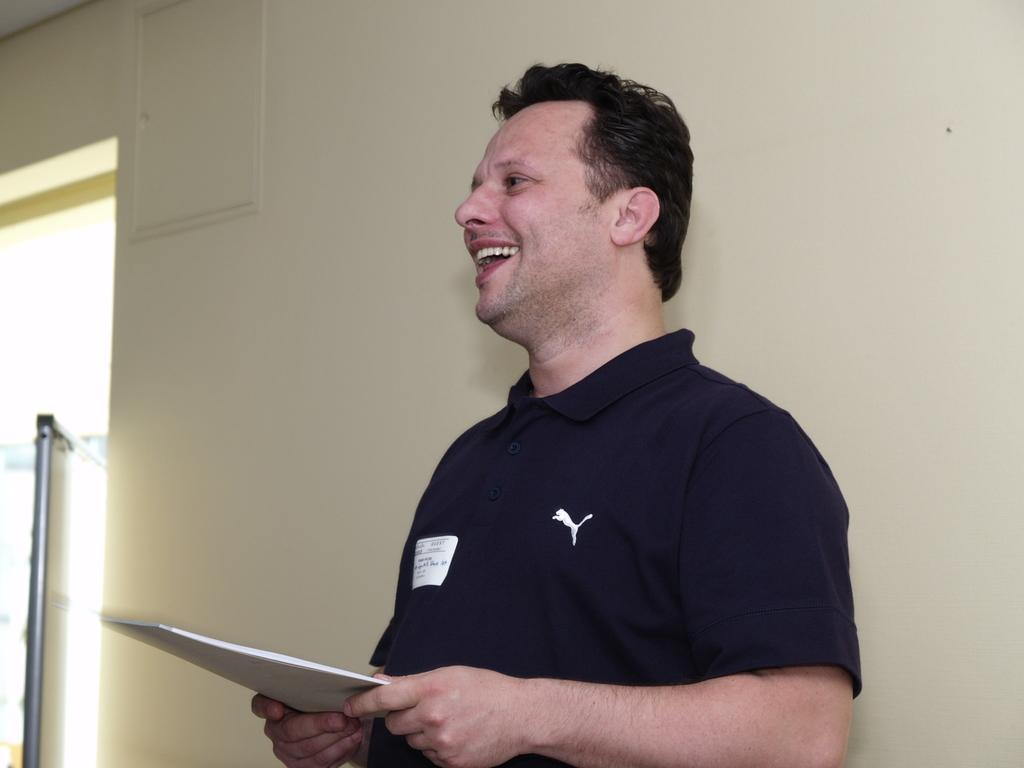Who is present in the image? There is a person in the image. Where is the person located? The person is standing in a room. What is the person wearing? The person is wearing a black t-shirt. What is the person holding in his hand? The person is holding something in his hand. What can be seen behind the person? There is a wall visible in the image. How does the person contribute to reducing pollution in the image? The image does not provide any information about pollution or the person's actions related to it. 